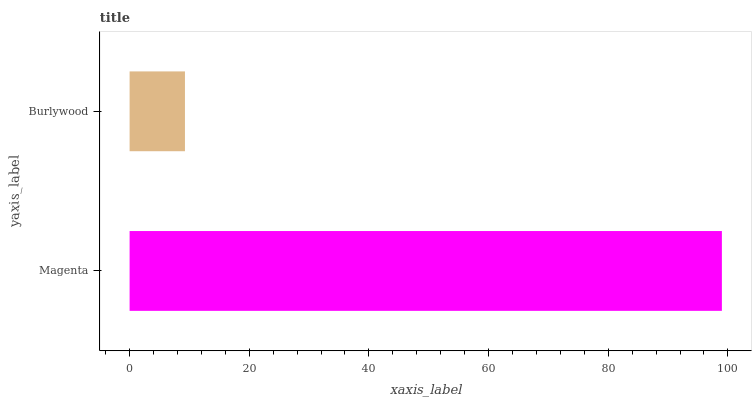Is Burlywood the minimum?
Answer yes or no. Yes. Is Magenta the maximum?
Answer yes or no. Yes. Is Burlywood the maximum?
Answer yes or no. No. Is Magenta greater than Burlywood?
Answer yes or no. Yes. Is Burlywood less than Magenta?
Answer yes or no. Yes. Is Burlywood greater than Magenta?
Answer yes or no. No. Is Magenta less than Burlywood?
Answer yes or no. No. Is Magenta the high median?
Answer yes or no. Yes. Is Burlywood the low median?
Answer yes or no. Yes. Is Burlywood the high median?
Answer yes or no. No. Is Magenta the low median?
Answer yes or no. No. 